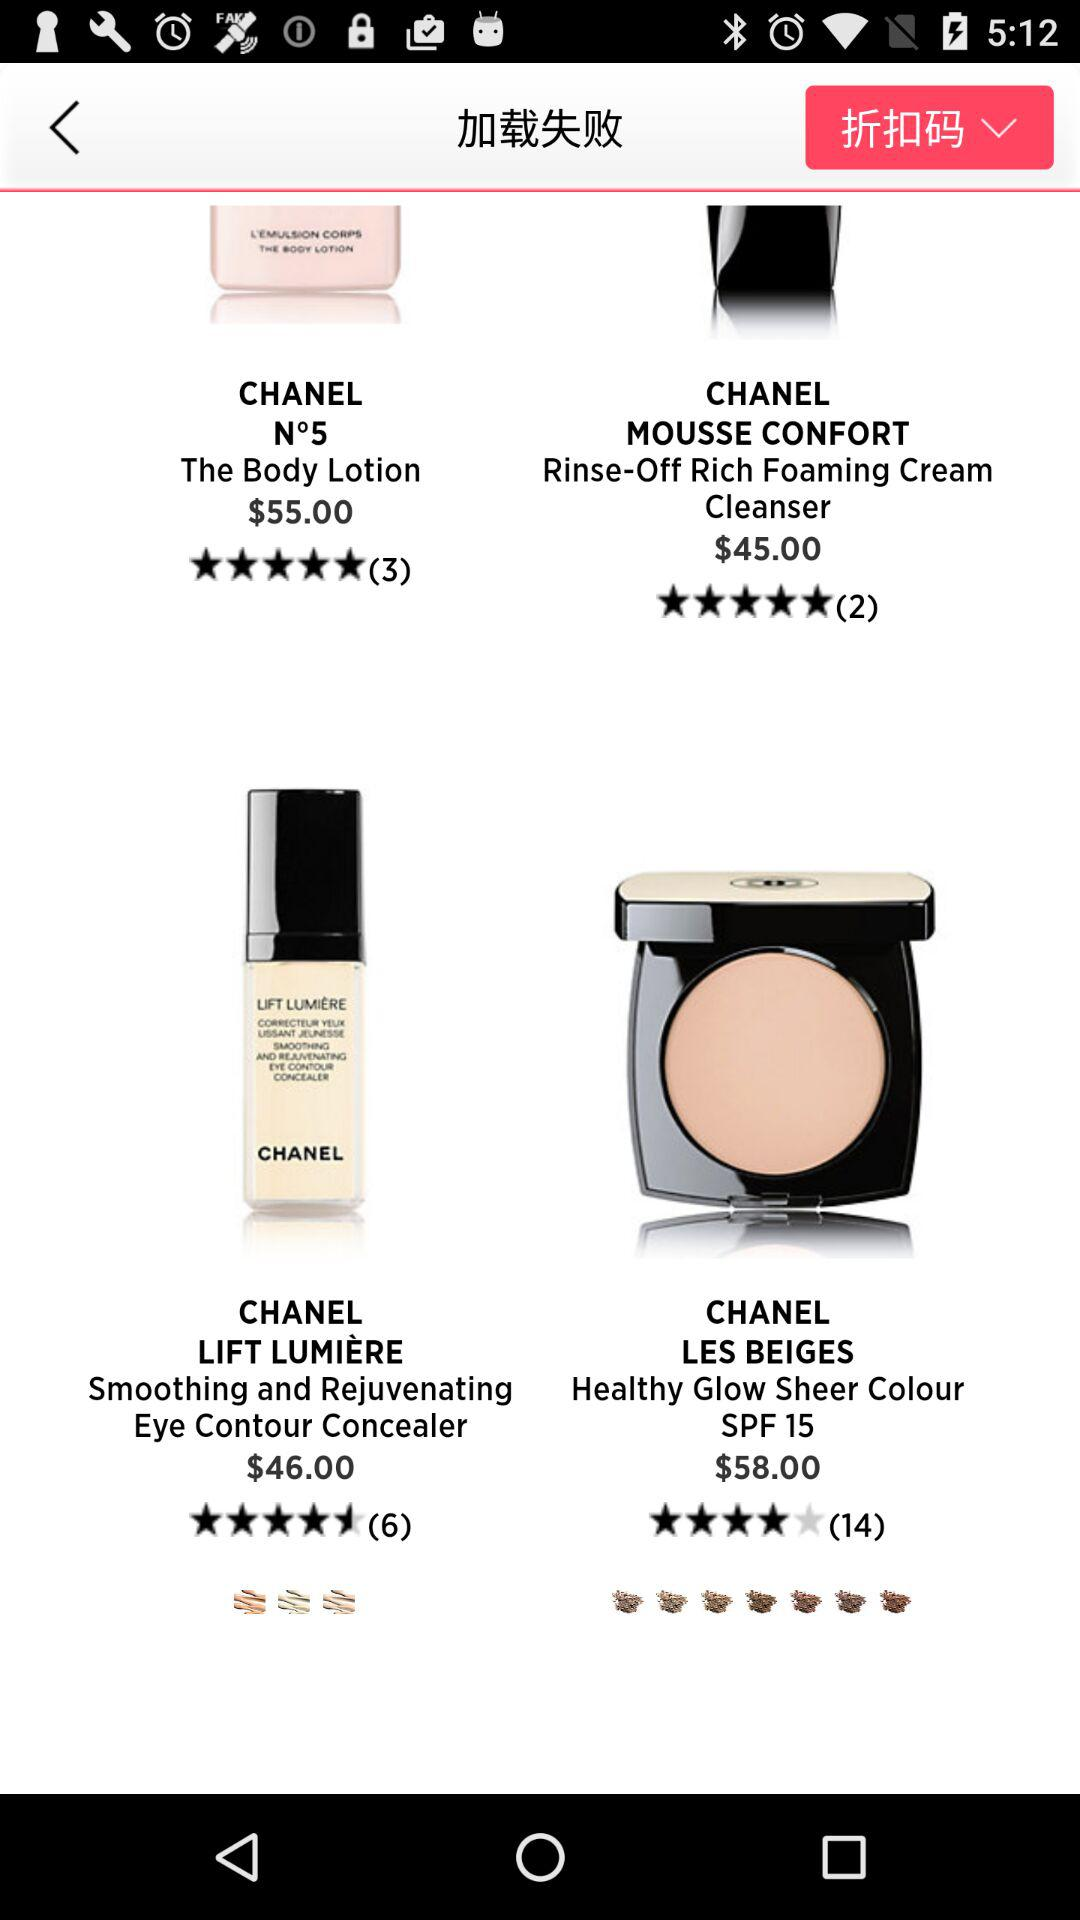How many reviews are there for "CHANEL MOUSSE CONFRONT Rinse-Off Rich Foaming Cream Cleanser"? There are 2 reviews. 